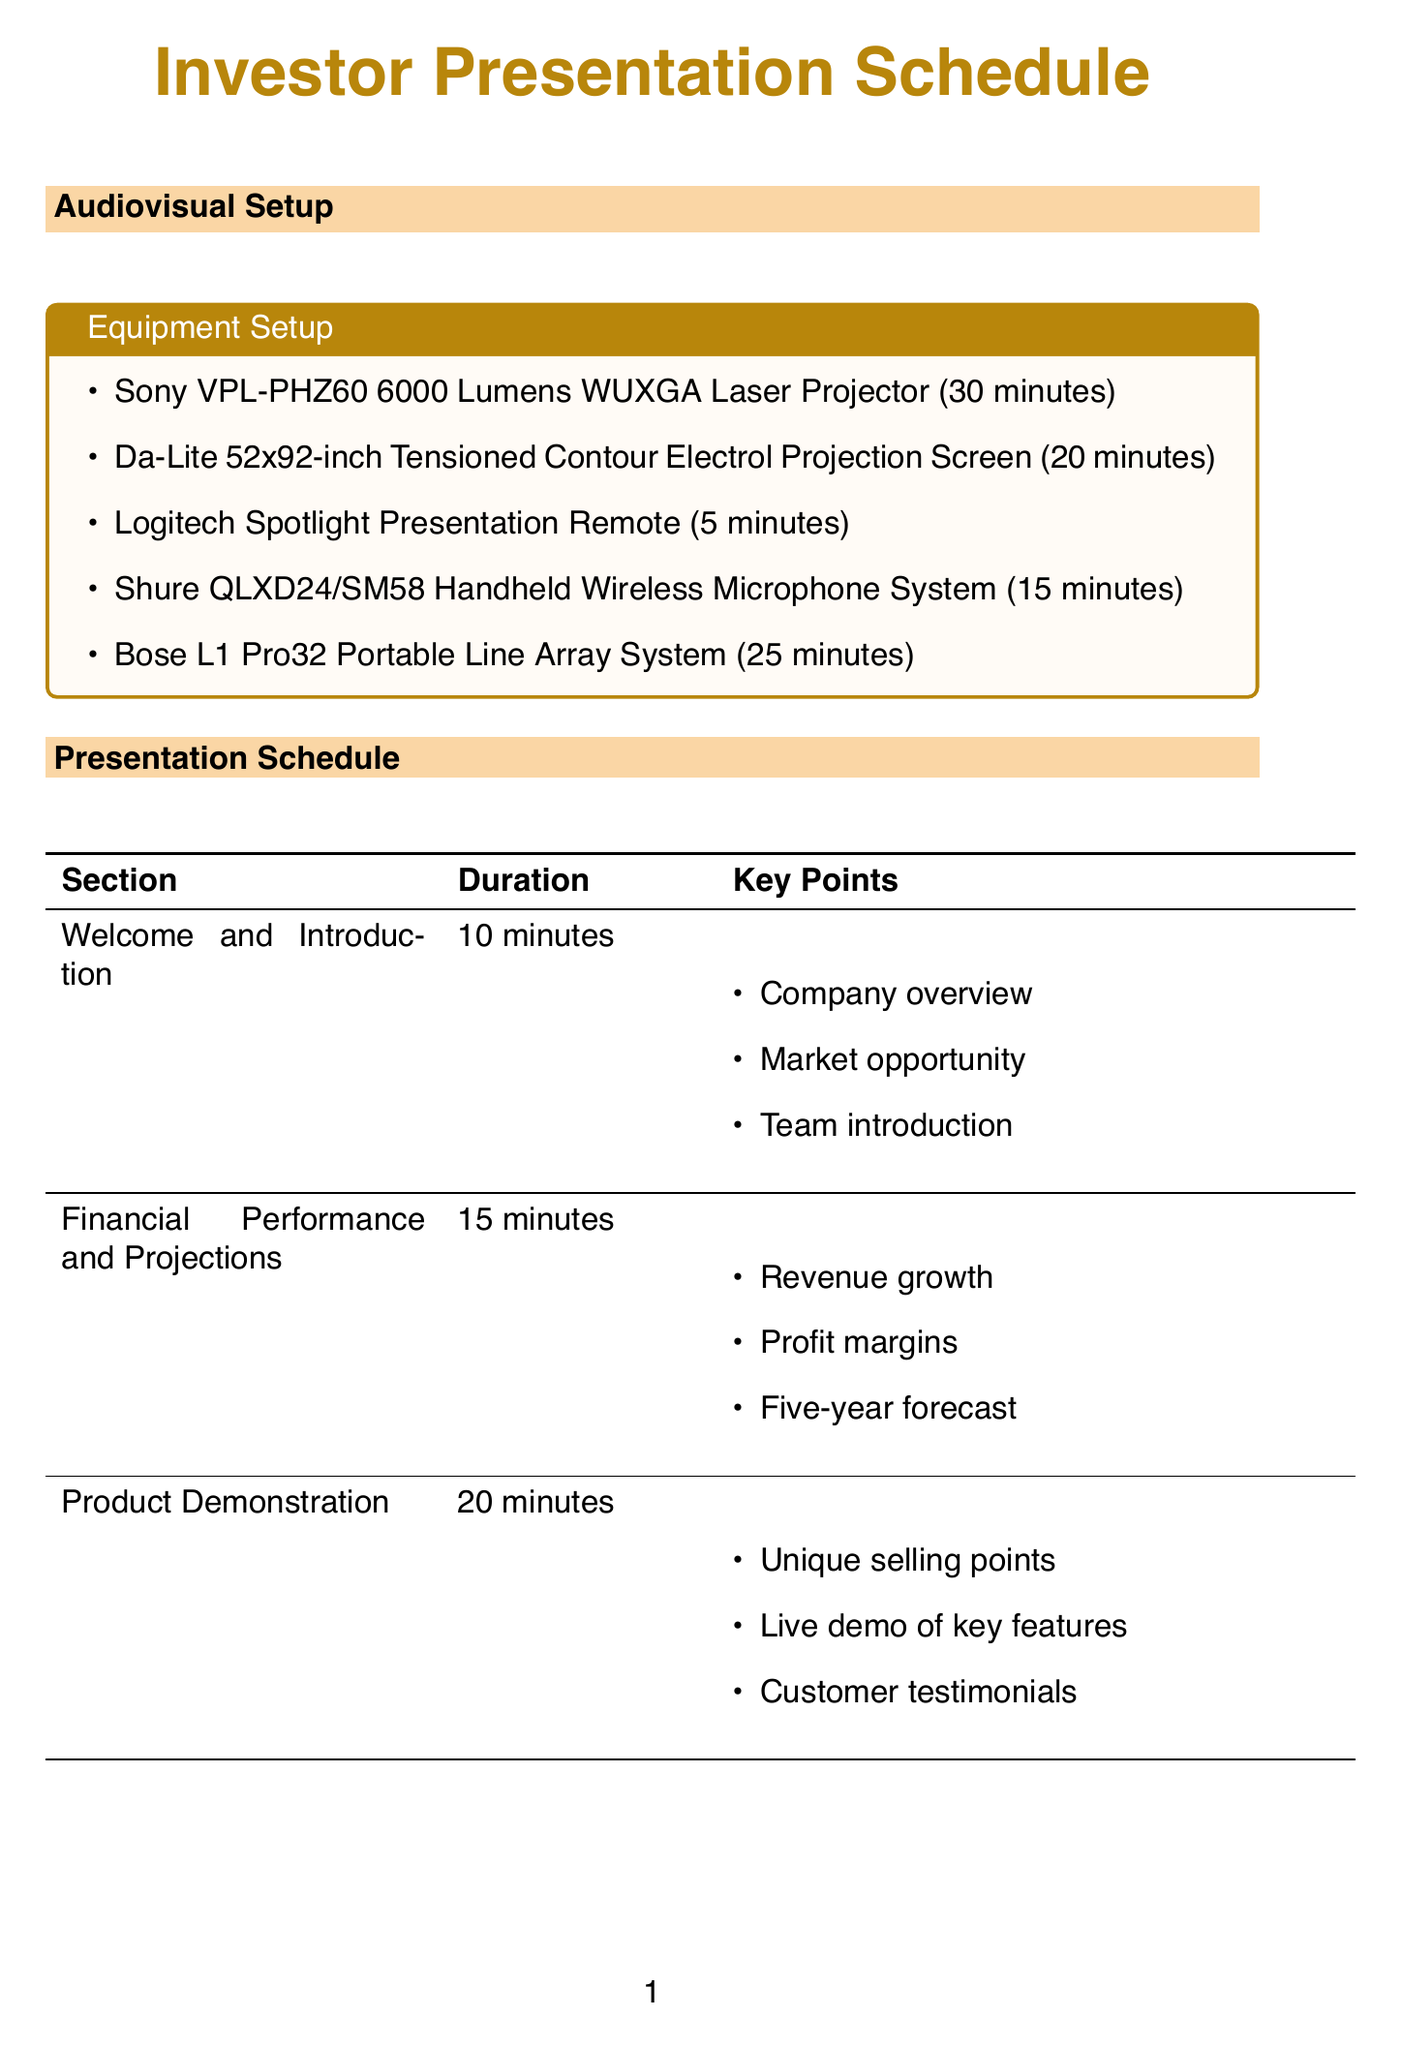What equipment is used for high-quality visuals? The document specifies the Sony VPL-PHZ60 6000 Lumens WUXGA Laser Projector for high-quality visuals.
Answer: Sony VPL-PHZ60 6000 Lumens WUXGA Laser Projector How long does it take to set up the main audio system? According to the document, the setup time for the Bose L1 Pro32 Portable Line Array System is 25 minutes.
Answer: 25 minutes Who presents the Investment Opportunity section? The schedule indicates that the Investment Opportunity section is presented by Sarah Johnson, the CEO.
Answer: Sarah Johnson What is the duration of the Q&A Session? The document lists the Q&A Session as lasting for 20 minutes.
Answer: 20 minutes Which course is served during guest arrival? The document states that appetizers are served during guest arrival and mingling.
Answer: Appetizers Which presenter discusses the marketing strategy? David Thompson, the CMO, is the presenter for the Marketing Strategy section.
Answer: David Thompson What unique feature is highlighted during the Product Demonstration? The document mentions that unique selling points are one of the key points highlighted during the Product Demonstration.
Answer: Unique selling points How many main course options are provided? The document lists three main course options: pan-seared salmon, herb-crusted chicken breast, and quinoa salad.
Answer: Three options What is included in the beverage selection? The beverage selection includes premium coffee and tea selection, sparkling water, and fresh-squeezed juices.
Answer: Coffee, tea, sparkling water, juices 